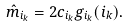Convert formula to latex. <formula><loc_0><loc_0><loc_500><loc_500>\hat { m } _ { i _ { k } } = 2 c _ { i _ { k } } g _ { i _ { k } } ( i _ { k } ) .</formula> 